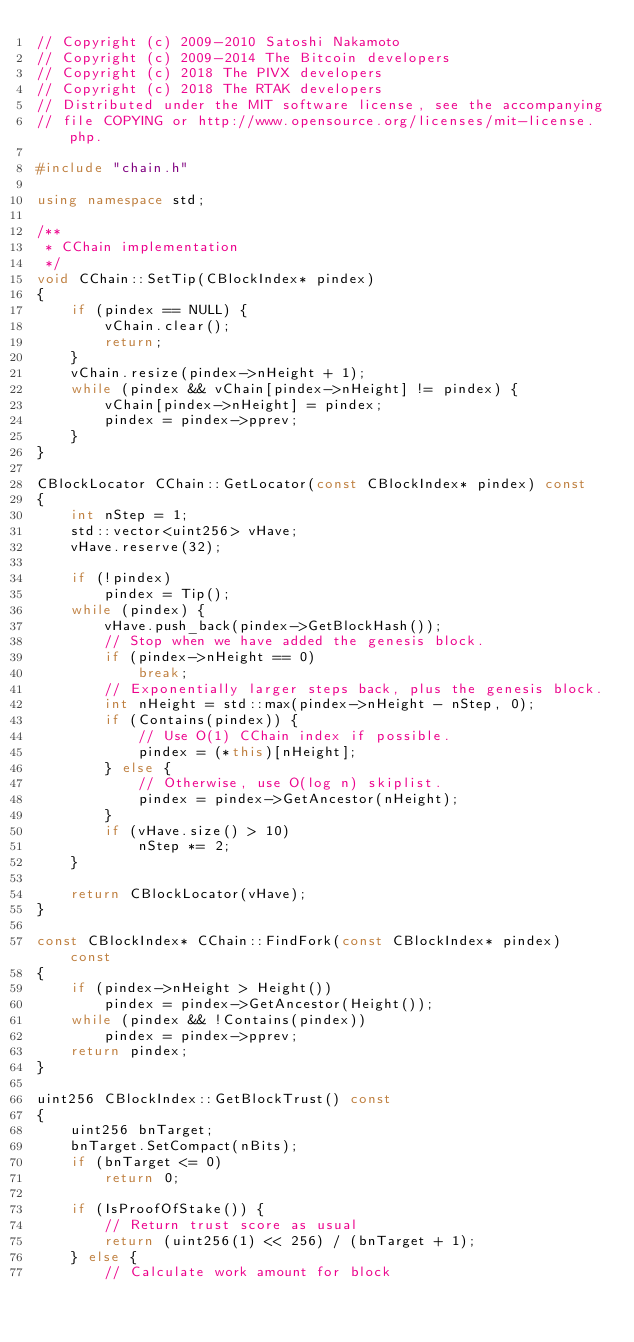Convert code to text. <code><loc_0><loc_0><loc_500><loc_500><_C++_>// Copyright (c) 2009-2010 Satoshi Nakamoto
// Copyright (c) 2009-2014 The Bitcoin developers
// Copyright (c) 2018 The PIVX developers
// Copyright (c) 2018 The RTAK developers
// Distributed under the MIT software license, see the accompanying
// file COPYING or http://www.opensource.org/licenses/mit-license.php.

#include "chain.h"

using namespace std;

/**
 * CChain implementation
 */
void CChain::SetTip(CBlockIndex* pindex)
{
    if (pindex == NULL) {
        vChain.clear();
        return;
    }
    vChain.resize(pindex->nHeight + 1);
    while (pindex && vChain[pindex->nHeight] != pindex) {
        vChain[pindex->nHeight] = pindex;
        pindex = pindex->pprev;
    }
}

CBlockLocator CChain::GetLocator(const CBlockIndex* pindex) const
{
    int nStep = 1;
    std::vector<uint256> vHave;
    vHave.reserve(32);

    if (!pindex)
        pindex = Tip();
    while (pindex) {
        vHave.push_back(pindex->GetBlockHash());
        // Stop when we have added the genesis block.
        if (pindex->nHeight == 0)
            break;
        // Exponentially larger steps back, plus the genesis block.
        int nHeight = std::max(pindex->nHeight - nStep, 0);
        if (Contains(pindex)) {
            // Use O(1) CChain index if possible.
            pindex = (*this)[nHeight];
        } else {
            // Otherwise, use O(log n) skiplist.
            pindex = pindex->GetAncestor(nHeight);
        }
        if (vHave.size() > 10)
            nStep *= 2;
    }

    return CBlockLocator(vHave);
}

const CBlockIndex* CChain::FindFork(const CBlockIndex* pindex) const
{
    if (pindex->nHeight > Height())
        pindex = pindex->GetAncestor(Height());
    while (pindex && !Contains(pindex))
        pindex = pindex->pprev;
    return pindex;
}

uint256 CBlockIndex::GetBlockTrust() const
{
    uint256 bnTarget;
    bnTarget.SetCompact(nBits);
    if (bnTarget <= 0)
        return 0;

    if (IsProofOfStake()) {
        // Return trust score as usual
        return (uint256(1) << 256) / (bnTarget + 1);
    } else {
        // Calculate work amount for block</code> 